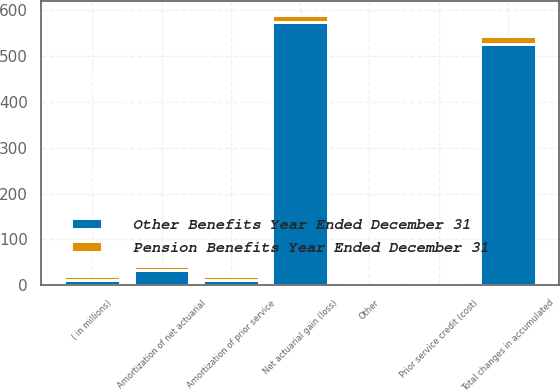Convert chart. <chart><loc_0><loc_0><loc_500><loc_500><stacked_bar_chart><ecel><fcel>( in millions)<fcel>Prior service credit (cost)<fcel>Amortization of prior service<fcel>Net actuarial gain (loss)<fcel>Amortization of net actuarial<fcel>Other<fcel>Total changes in accumulated<nl><fcel>Other Benefits Year Ended December 31<fcel>10.5<fcel>0<fcel>12<fcel>573<fcel>33<fcel>1<fcel>527<nl><fcel>Pension Benefits Year Ended December 31<fcel>10.5<fcel>0<fcel>9<fcel>17<fcel>9<fcel>0<fcel>17<nl></chart> 